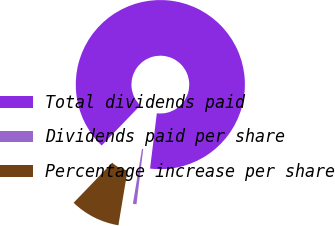Convert chart. <chart><loc_0><loc_0><loc_500><loc_500><pie_chart><fcel>Total dividends paid<fcel>Dividends paid per share<fcel>Percentage increase per share<nl><fcel>89.74%<fcel>0.68%<fcel>9.58%<nl></chart> 